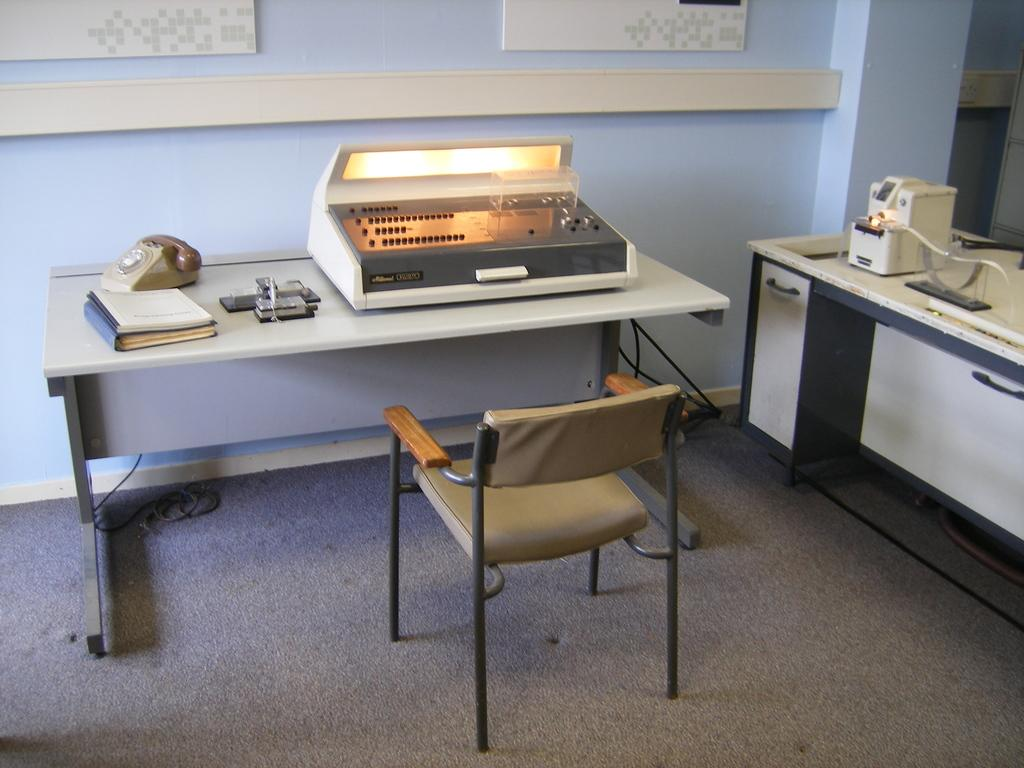What objects are on the tables in the image? There are machines, a telephone, and books on the tables in the image. What can be seen above the carpet in the image? There is a cable and a chair above the carpet in the image. What is visible on the wall in the image? The wall is visible in the image, but no specific details are provided about what is on the wall. What type of beef is being served on the table in the image? There is no beef present in the image; the objects on the tables are machines, a telephone, and books. Can you see any feathers on the chair above the carpet in the image? There is no mention of feathers in the image; the chair above the carpet is simply a chair. 